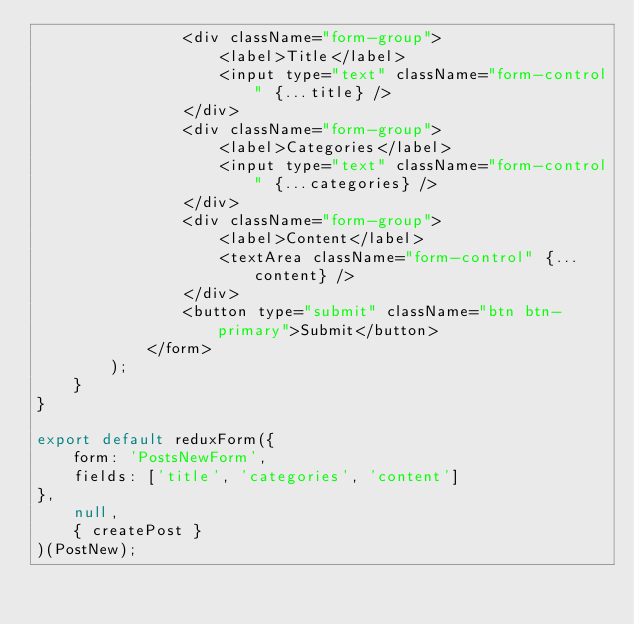Convert code to text. <code><loc_0><loc_0><loc_500><loc_500><_JavaScript_>                <div className="form-group">
                    <label>Title</label>
                    <input type="text" className="form-control" {...title} />
                </div>
                <div className="form-group">
                    <label>Categories</label>
                    <input type="text" className="form-control" {...categories} />
                </div>
                <div className="form-group">
                    <label>Content</label>
                    <textArea className="form-control" {...content} />
                </div>
                <button type="submit" className="btn btn-primary">Submit</button>
            </form>
        );
    }
}

export default reduxForm({
    form: 'PostsNewForm',
    fields: ['title', 'categories', 'content']
},
    null,
    { createPost }
)(PostNew);</code> 